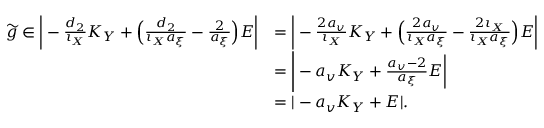Convert formula to latex. <formula><loc_0><loc_0><loc_500><loc_500>\begin{array} { r l } { \widetilde { g } \in \left | - \frac { d _ { 2 } } { \iota _ { X } } K _ { Y } + \left ( \frac { d _ { 2 } } { \iota _ { X } a _ { \xi } } - \frac { 2 } { a _ { \xi } } \right ) E \right | } & { = \left | - \frac { 2 a _ { v } } { \iota _ { X } } K _ { Y } + \left ( \frac { 2 a _ { v } } { \iota _ { X } a _ { \xi } } - \frac { 2 \iota _ { X } } { \iota _ { X } a _ { \xi } } \right ) E \right | } \\ & { = \left | - a _ { v } K _ { Y } + \frac { a _ { v } - 2 } { a _ { \xi } } E \right | } \\ & { = | - a _ { v } K _ { Y } + E | . } \end{array}</formula> 